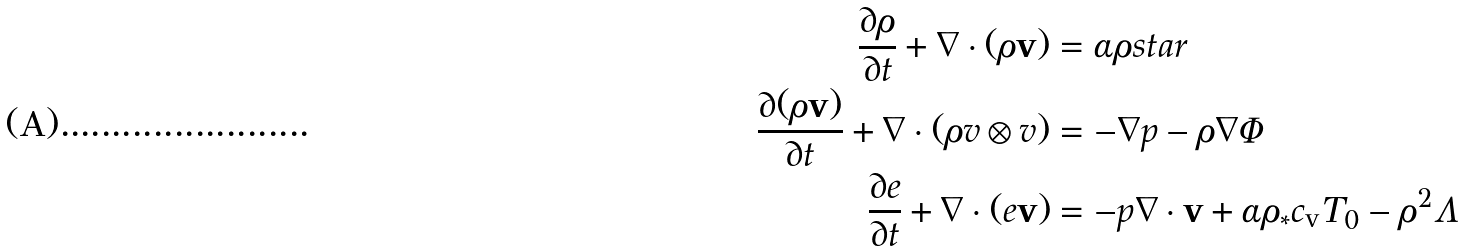Convert formula to latex. <formula><loc_0><loc_0><loc_500><loc_500>\frac { \partial \rho } { \partial t } + \nabla \cdot ( \rho { \mathbf v } ) & = \alpha \rho s t a r \\ \frac { \partial ( \rho { \mathbf v } ) } { \partial t } + \nabla \cdot ( \rho v \otimes v ) & = - \nabla p - \rho \nabla \Phi \\ \frac { \partial e } { \partial t } + \nabla \cdot ( e { \mathbf v } ) & = - p \nabla \cdot { \mathbf v } + \alpha \rho _ { * } c _ { \text  v} T_{0}  -\rho^{2} \Lambda</formula> 